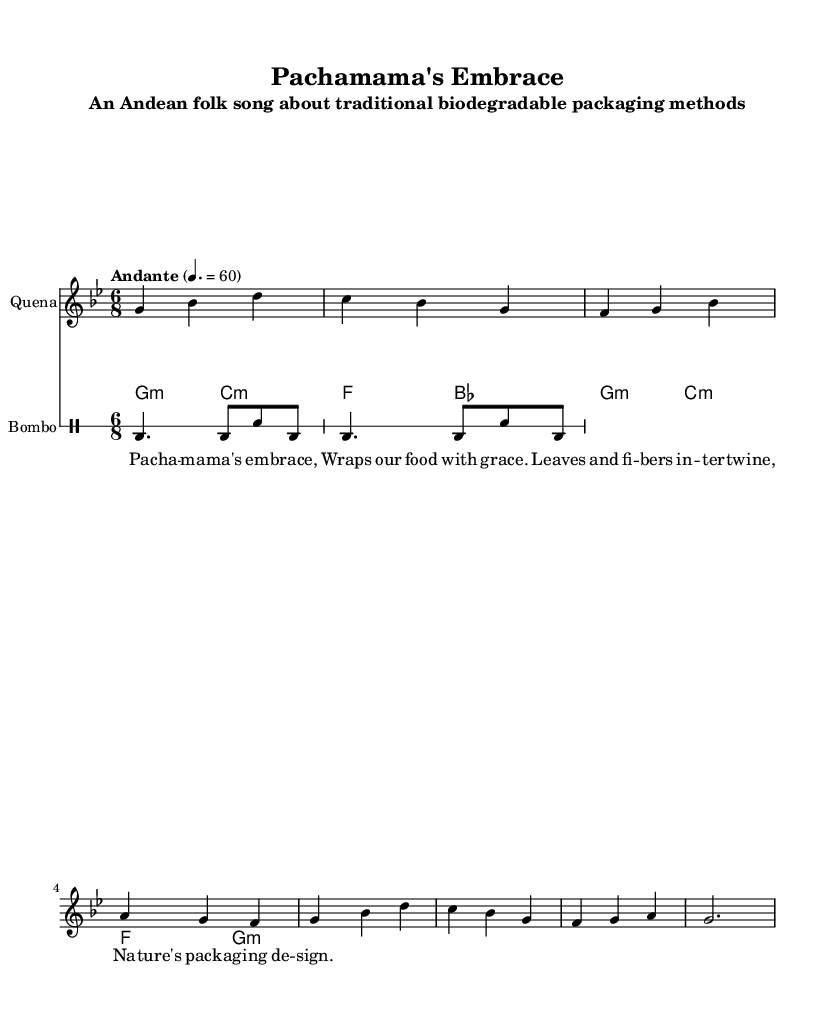What is the key signature of this music? The key signature is G minor, which has two flats (B flat and E flat).
Answer: G minor What is the time signature of this music? The time signature is indicated at the start of the piece as 6/8, which signifies six eighth notes per measure.
Answer: 6/8 What is the tempo marking of this piece? The tempo marking indicates "Andante" at a speed of 60 beats per minute, suggesting a moderate walking pace.
Answer: Andante How many measures are there in the quena part? The quena part has a total of eight measures, as evidenced by counting each measure within the written section.
Answer: Eight What is the rhythmic pattern used in the bombo part? The bombo part primarily uses a rhythmic pattern of bass drum hits followed by a snare, which is repeated twice.
Answer: Bass drum and snare How does the lyrical theme relate to the music's purpose? The lyrics emphasize nature and traditional packaging, aligning with sustainability themes, which is expressed through the use of biodegradable materials.
Answer: Sustainability What instrument is likely to be the main melody carrier in this piece? The quena takes the lead as the main melody instrument due to its prominent melodic line at the start of the score.
Answer: Quena 